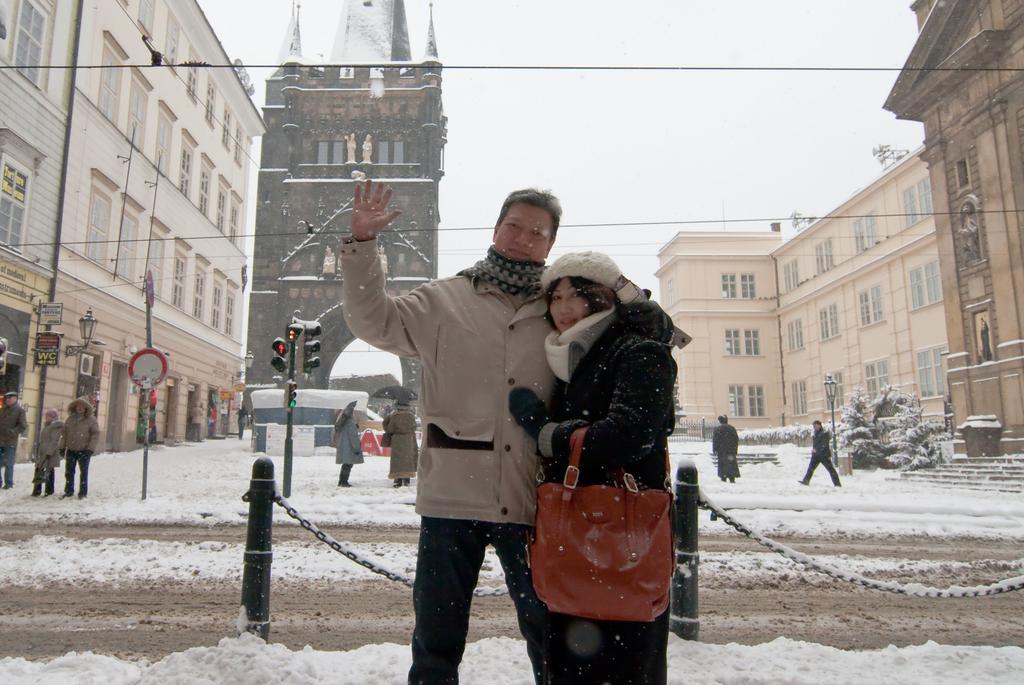Can you describe this image briefly? In the foreground of the picture there is a couple standing. In the center of the picture there are people, poles, street light, signal light, snow, road, cables and other objects. In the background there are buildings, trees, plants and sky. 